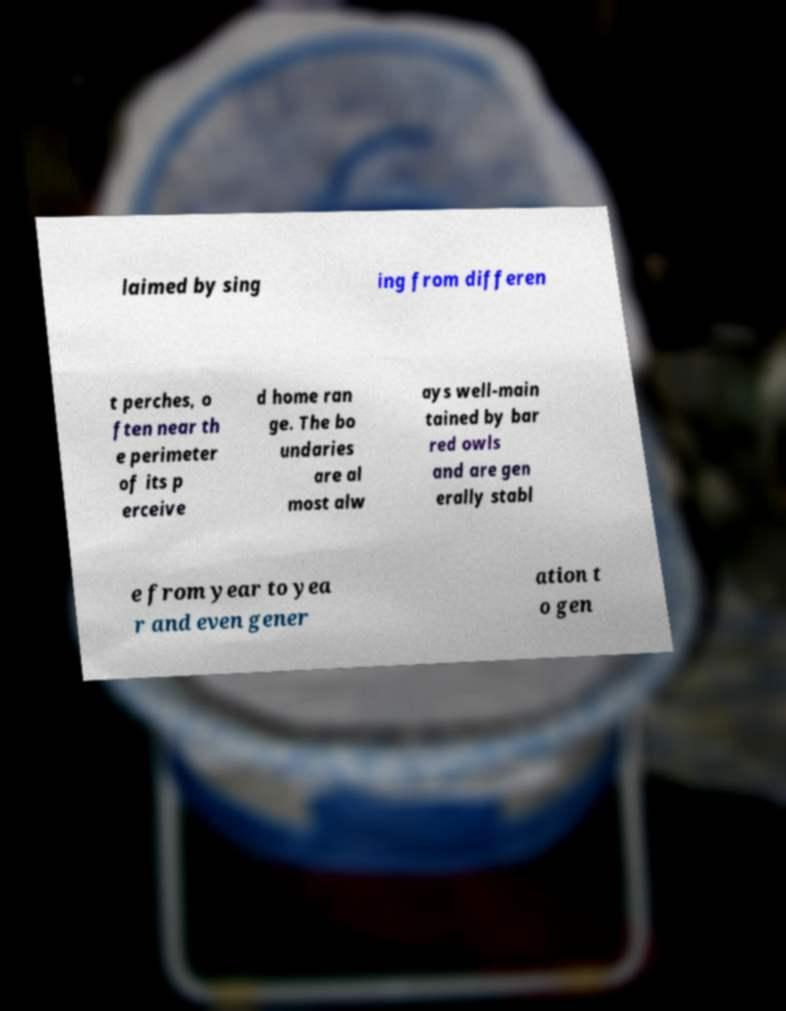Could you extract and type out the text from this image? laimed by sing ing from differen t perches, o ften near th e perimeter of its p erceive d home ran ge. The bo undaries are al most alw ays well-main tained by bar red owls and are gen erally stabl e from year to yea r and even gener ation t o gen 